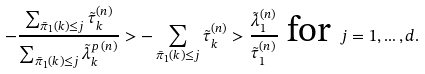Convert formula to latex. <formula><loc_0><loc_0><loc_500><loc_500>- \frac { \sum _ { \bar { \pi } _ { 1 } ( k ) \leq j } \tilde { \tau } ^ { ( n ) } _ { k } } { \sum _ { \bar { \pi } _ { 1 } ( k ) \leq j } \tilde { \lambda } ^ { p \, ( n ) } _ { k } } > - \sum _ { \bar { \pi } _ { 1 } ( k ) \leq j } \tilde { \tau } ^ { ( n ) } _ { k } > \frac { \tilde { \lambda } ^ { ( n ) } _ { 1 } } { \tilde { \tau } ^ { ( n ) } _ { 1 } } \text { for } j = 1 , \dots , d .</formula> 